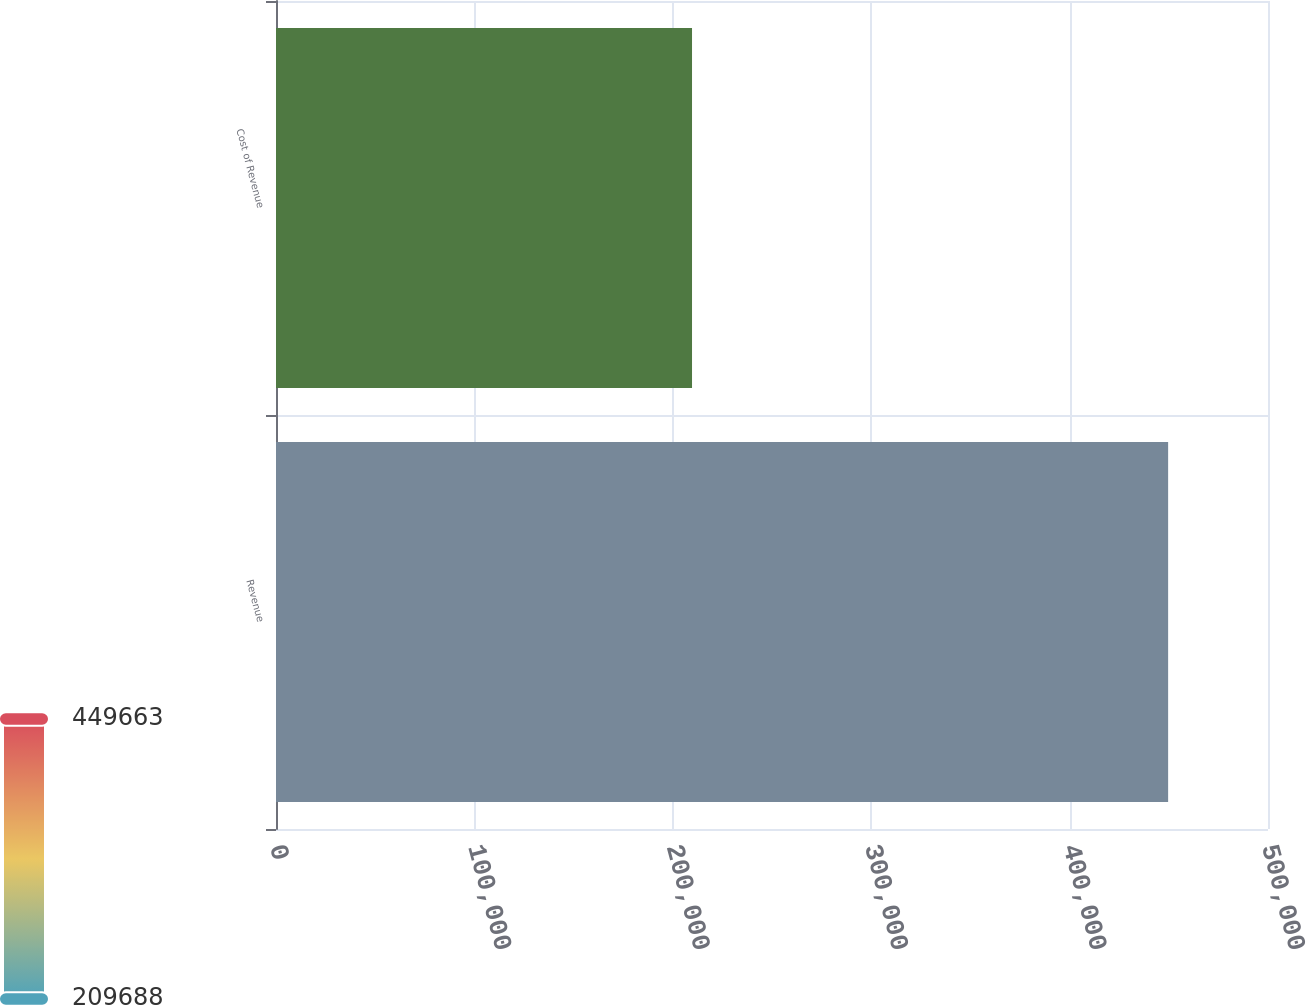Convert chart. <chart><loc_0><loc_0><loc_500><loc_500><bar_chart><fcel>Revenue<fcel>Cost of Revenue<nl><fcel>449663<fcel>209688<nl></chart> 